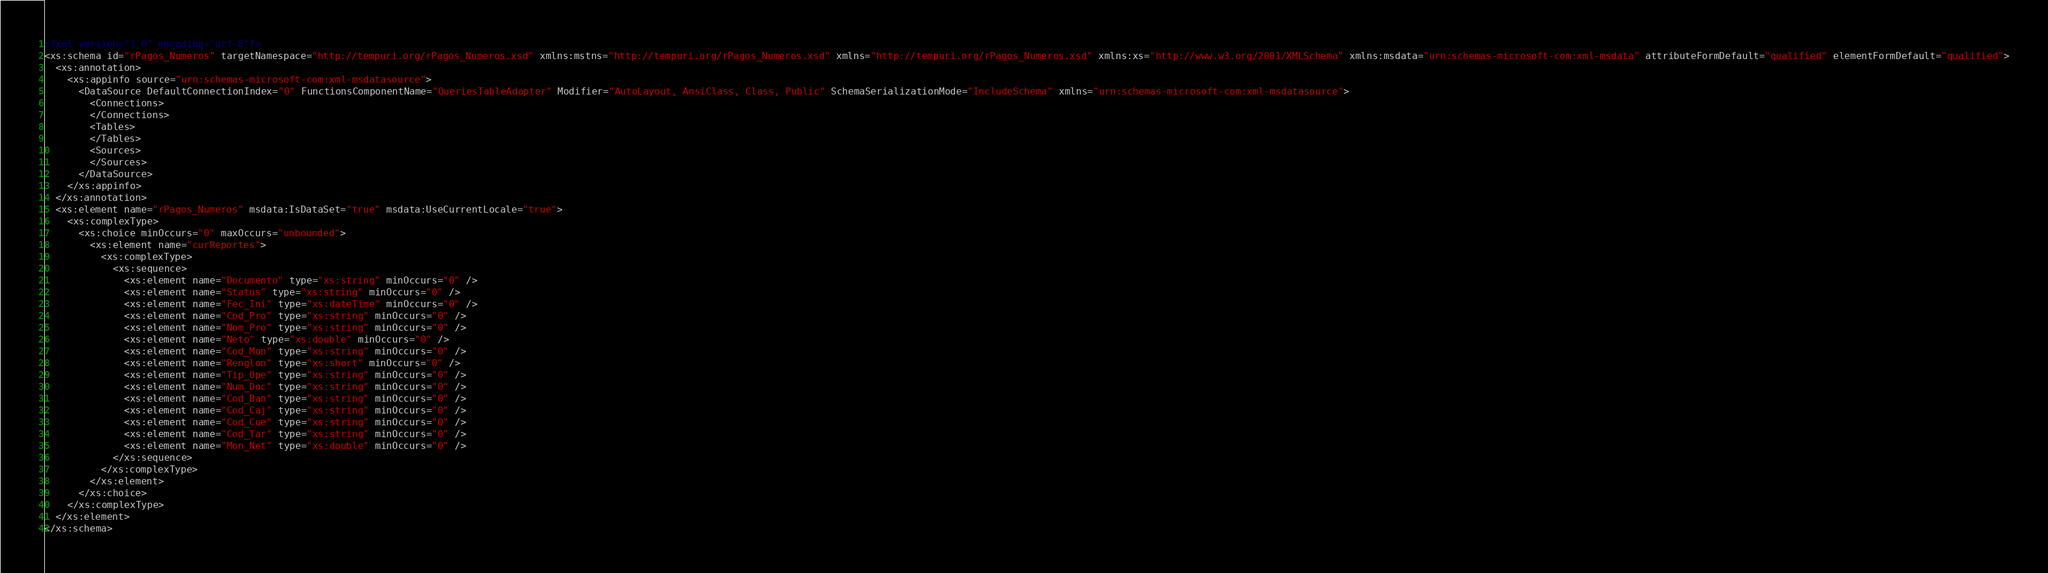<code> <loc_0><loc_0><loc_500><loc_500><_XML_><?xml version="1.0" encoding="utf-8"?>
<xs:schema id="rPagos_Numeros" targetNamespace="http://tempuri.org/rPagos_Numeros.xsd" xmlns:mstns="http://tempuri.org/rPagos_Numeros.xsd" xmlns="http://tempuri.org/rPagos_Numeros.xsd" xmlns:xs="http://www.w3.org/2001/XMLSchema" xmlns:msdata="urn:schemas-microsoft-com:xml-msdata" attributeFormDefault="qualified" elementFormDefault="qualified">
  <xs:annotation>
    <xs:appinfo source="urn:schemas-microsoft-com:xml-msdatasource">
      <DataSource DefaultConnectionIndex="0" FunctionsComponentName="QueriesTableAdapter" Modifier="AutoLayout, AnsiClass, Class, Public" SchemaSerializationMode="IncludeSchema" xmlns="urn:schemas-microsoft-com:xml-msdatasource">
        <Connections>
        </Connections>
        <Tables>
        </Tables>
        <Sources>
        </Sources>
      </DataSource>
    </xs:appinfo>
  </xs:annotation>
  <xs:element name="rPagos_Numeros" msdata:IsDataSet="true" msdata:UseCurrentLocale="true">
    <xs:complexType>
      <xs:choice minOccurs="0" maxOccurs="unbounded">
        <xs:element name="curReportes">
          <xs:complexType>
            <xs:sequence>
              <xs:element name="Documento" type="xs:string" minOccurs="0" />
              <xs:element name="Status" type="xs:string" minOccurs="0" />
              <xs:element name="Fec_Ini" type="xs:dateTime" minOccurs="0" />
              <xs:element name="Cod_Pro" type="xs:string" minOccurs="0" />
              <xs:element name="Nom_Pro" type="xs:string" minOccurs="0" />
              <xs:element name="Neto" type="xs:double" minOccurs="0" />
              <xs:element name="Cod_Mon" type="xs:string" minOccurs="0" />
              <xs:element name="Renglon" type="xs:short" minOccurs="0" />
              <xs:element name="Tip_Ope" type="xs:string" minOccurs="0" />
              <xs:element name="Num_Doc" type="xs:string" minOccurs="0" />
              <xs:element name="Cod_Ban" type="xs:string" minOccurs="0" />
              <xs:element name="Cod_Caj" type="xs:string" minOccurs="0" />
              <xs:element name="Cod_Cue" type="xs:string" minOccurs="0" />
              <xs:element name="Cod_Tar" type="xs:string" minOccurs="0" />
              <xs:element name="Mon_Net" type="xs:double" minOccurs="0" />
            </xs:sequence>
          </xs:complexType>
        </xs:element>
      </xs:choice>
    </xs:complexType>
  </xs:element>
</xs:schema></code> 